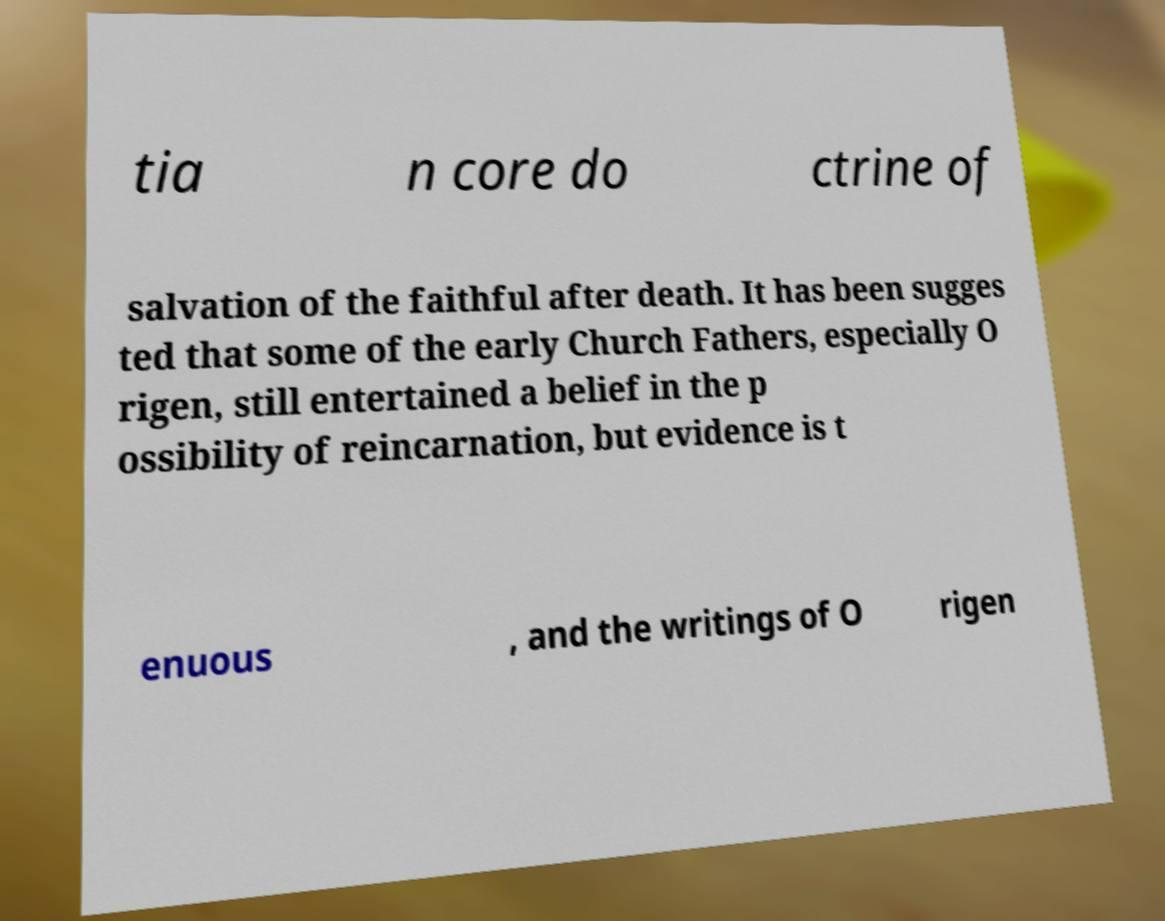Can you accurately transcribe the text from the provided image for me? tia n core do ctrine of salvation of the faithful after death. It has been sugges ted that some of the early Church Fathers, especially O rigen, still entertained a belief in the p ossibility of reincarnation, but evidence is t enuous , and the writings of O rigen 